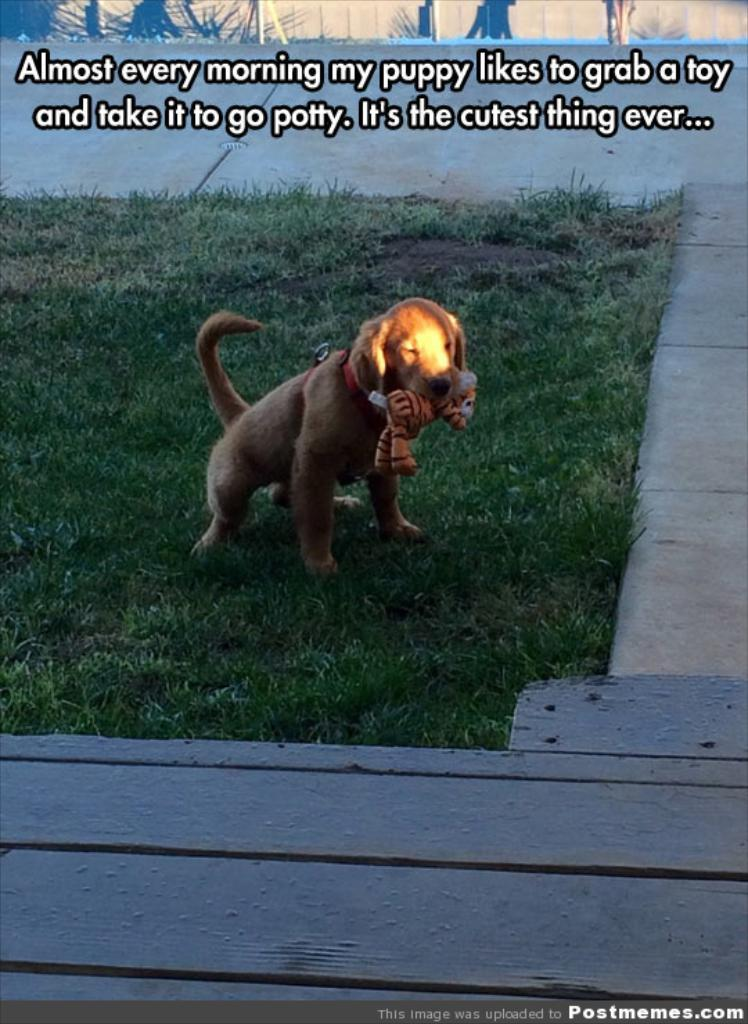What type of animal is in the image? There is a dog in the image. What is the dog doing in the image? The dog is holding something with its mouth. What is the background of the image? There is grass at the bottom of the image. Is there any text present in the image? Yes, there is text visible in the image. What is attached to the dog's neck? The dog has a strap on its neck. What type of cabbage is the dog eating in the image? There is no cabbage present in the image, and the dog is not eating anything. Can you see the dog's lip in the image? The dog's lip is not a focus of the image, but it is visible as part of the dog's face. 